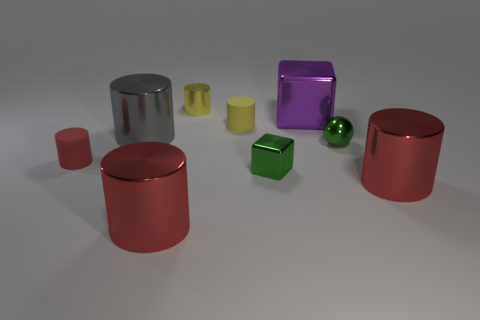Do the small metal ball and the object left of the gray metal cylinder have the same color?
Offer a terse response. No. The large thing that is both to the right of the small yellow shiny cylinder and behind the small metal ball is made of what material?
Keep it short and to the point. Metal. There is a sphere that is the same color as the tiny cube; what is its size?
Make the answer very short. Small. There is a matte thing right of the red rubber cylinder; is it the same shape as the small green shiny thing that is on the left side of the purple metal object?
Your answer should be very brief. No. Are any green balls visible?
Offer a very short reply. Yes. There is another rubber object that is the same shape as the red matte object; what is its color?
Ensure brevity in your answer.  Yellow. The rubber cylinder that is the same size as the red rubber thing is what color?
Give a very brief answer. Yellow. Is the material of the big gray cylinder the same as the big purple cube?
Offer a terse response. Yes. How many large cylinders have the same color as the small shiny ball?
Offer a very short reply. 0. Does the large block have the same color as the tiny sphere?
Provide a short and direct response. No. 